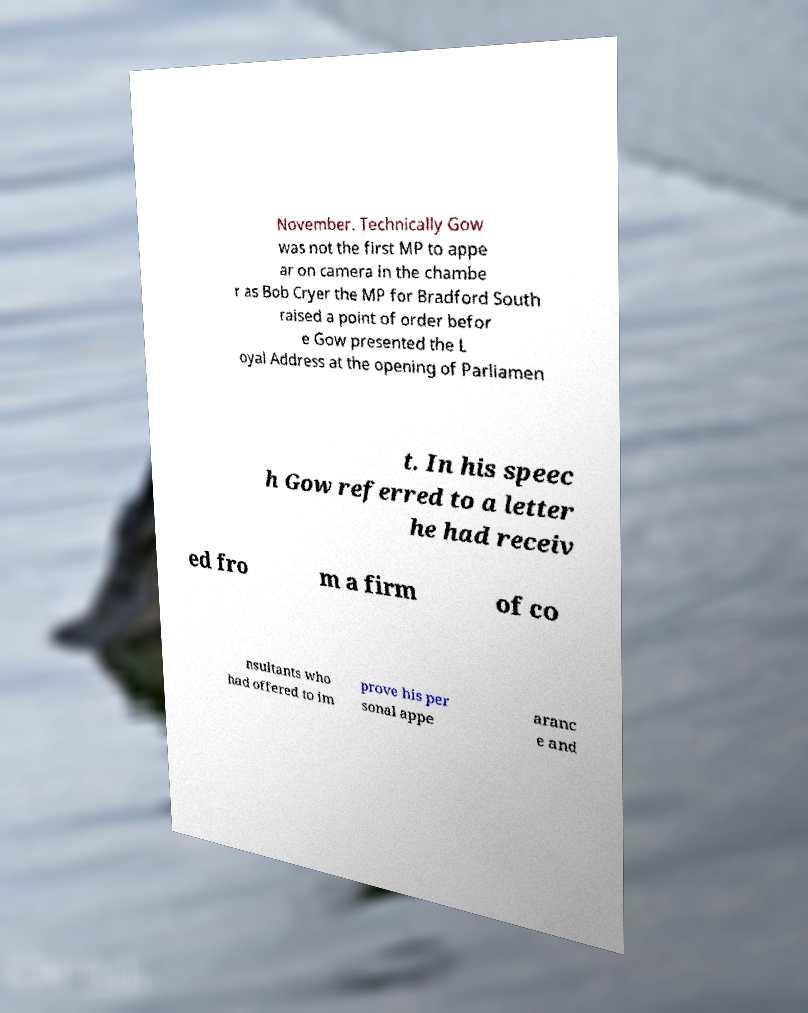Can you read and provide the text displayed in the image?This photo seems to have some interesting text. Can you extract and type it out for me? November. Technically Gow was not the first MP to appe ar on camera in the chambe r as Bob Cryer the MP for Bradford South raised a point of order befor e Gow presented the L oyal Address at the opening of Parliamen t. In his speec h Gow referred to a letter he had receiv ed fro m a firm of co nsultants who had offered to im prove his per sonal appe aranc e and 